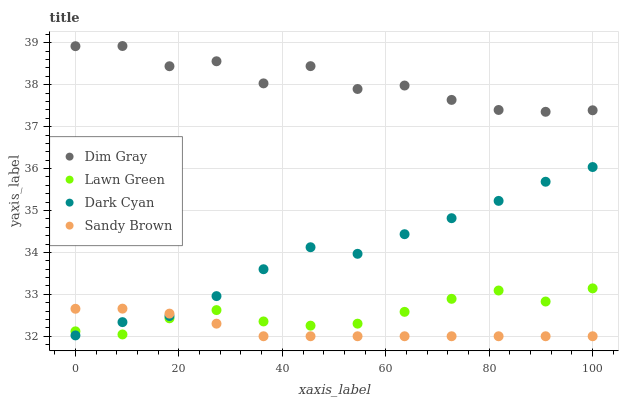Does Sandy Brown have the minimum area under the curve?
Answer yes or no. Yes. Does Dim Gray have the maximum area under the curve?
Answer yes or no. Yes. Does Lawn Green have the minimum area under the curve?
Answer yes or no. No. Does Lawn Green have the maximum area under the curve?
Answer yes or no. No. Is Sandy Brown the smoothest?
Answer yes or no. Yes. Is Dim Gray the roughest?
Answer yes or no. Yes. Is Lawn Green the smoothest?
Answer yes or no. No. Is Lawn Green the roughest?
Answer yes or no. No. Does Sandy Brown have the lowest value?
Answer yes or no. Yes. Does Lawn Green have the lowest value?
Answer yes or no. No. Does Dim Gray have the highest value?
Answer yes or no. Yes. Does Lawn Green have the highest value?
Answer yes or no. No. Is Lawn Green less than Dim Gray?
Answer yes or no. Yes. Is Dim Gray greater than Dark Cyan?
Answer yes or no. Yes. Does Dark Cyan intersect Sandy Brown?
Answer yes or no. Yes. Is Dark Cyan less than Sandy Brown?
Answer yes or no. No. Is Dark Cyan greater than Sandy Brown?
Answer yes or no. No. Does Lawn Green intersect Dim Gray?
Answer yes or no. No. 